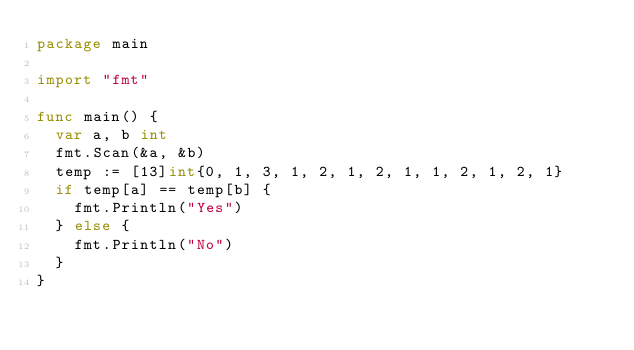Convert code to text. <code><loc_0><loc_0><loc_500><loc_500><_Go_>package main

import "fmt"

func main() {
	var a, b int
	fmt.Scan(&a, &b)
	temp := [13]int{0, 1, 3, 1, 2, 1, 2, 1, 1, 2, 1, 2, 1}
	if temp[a] == temp[b] {
		fmt.Println("Yes")
	} else {
		fmt.Println("No")
	}
}
</code> 